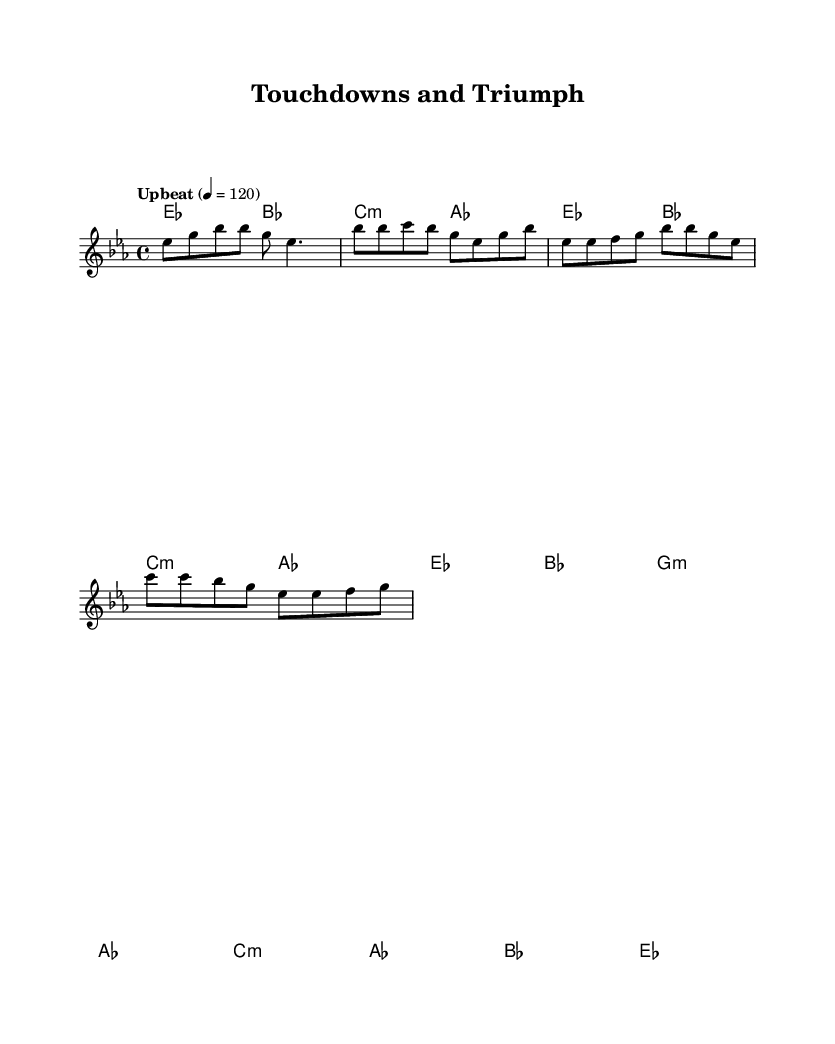What is the key signature of this music? The key signature is indicated at the beginning of the score, showing two flat symbols on the staff, which corresponds to E flat major.
Answer: E flat major What is the time signature of this piece? The time signature is located at the beginning of the score right after the key signature and shows 4 over 4, indicating that there are four beats in each measure.
Answer: 4/4 What is the tempo marking for this music? The tempo marking appears at the start of the score and states "Upbeat" with a metronome marking of 120 beats per minute, indicating a lively pace.
Answer: Upbeat 120 How many sections are present in the music? By analyzing the structure outlined in the sheet music (Intro, Verse, Chorus, Bridge), we can conclude that there are four distinct sections, each contributing to the overall piece.
Answer: Four What is the most frequently occurring chord in the verse? By examining the chord progression in the verse, we find that the E flat major chord appears most frequently compared to the others, thus being the dominant chord in that section.
Answer: E flat major What is the mood conveyed by the tempo and style of the piece? The upbeat tempo of 120, combined with the rhythmic and lively style characteristic of funk, suggests a celebratory and energetic mood, typical of an anthem celebrating victories.
Answer: Celebratory Which type of musical harmony is predominantly used in this sheet music? The music features a combination of major and minor chords, but emphasizing major chords is a hallmark of funk music, adding to the uplifting feel of the anthem.
Answer: Major chords 